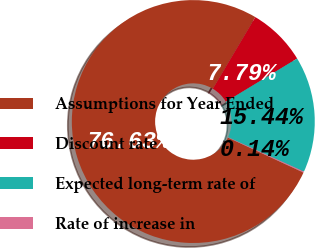<chart> <loc_0><loc_0><loc_500><loc_500><pie_chart><fcel>Assumptions for Year Ended<fcel>Discount rate<fcel>Expected long-term rate of<fcel>Rate of increase in<nl><fcel>76.62%<fcel>7.79%<fcel>15.44%<fcel>0.14%<nl></chart> 